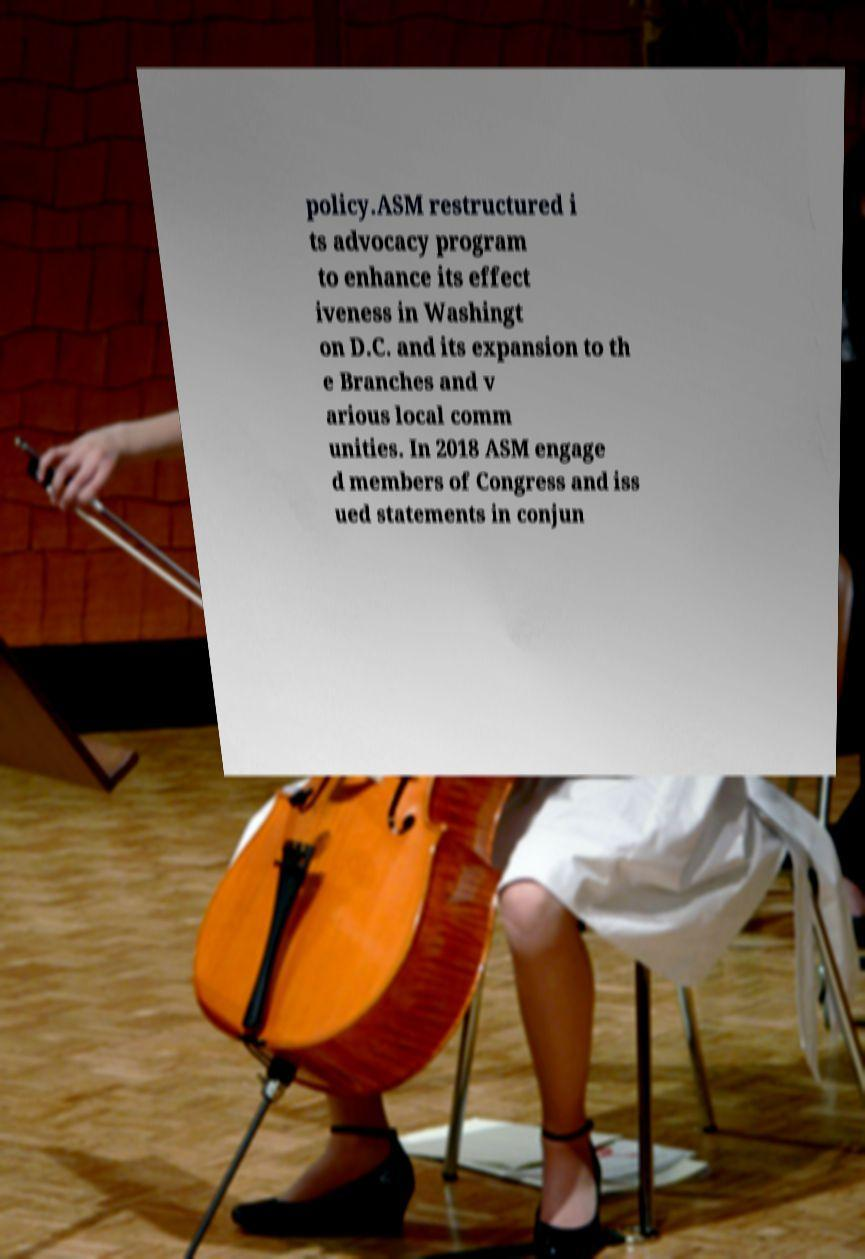Could you assist in decoding the text presented in this image and type it out clearly? policy.ASM restructured i ts advocacy program to enhance its effect iveness in Washingt on D.C. and its expansion to th e Branches and v arious local comm unities. In 2018 ASM engage d members of Congress and iss ued statements in conjun 